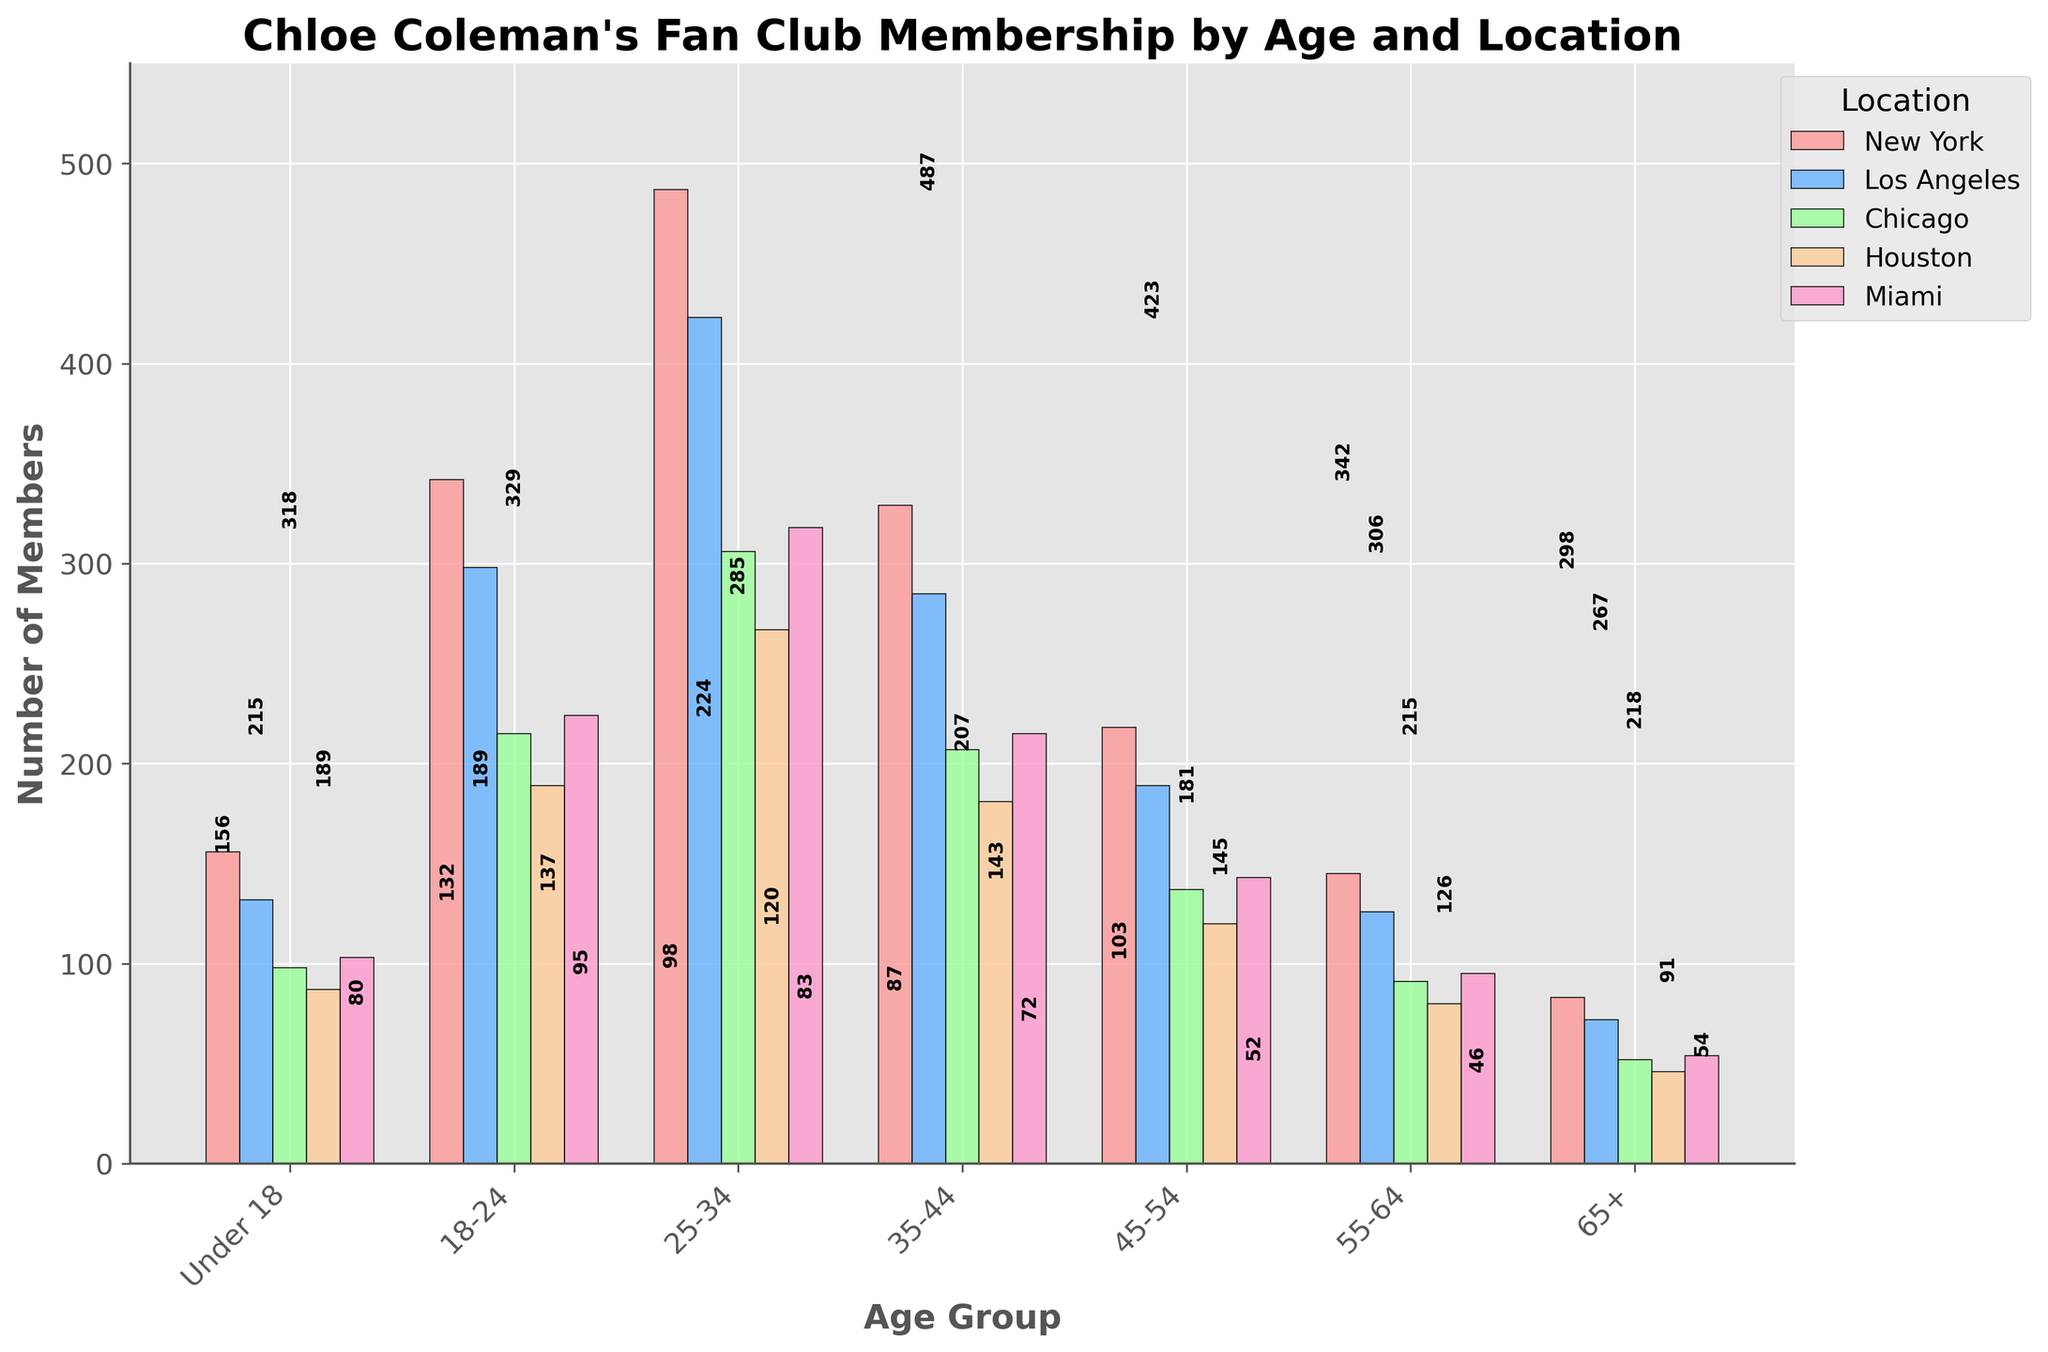What's the total number of members in the 25-34 age group across all locations? Sum the values for the 25-34 age group across New York, Los Angeles, Chicago, Houston, and Miami: (487 + 423 + 306 + 267 + 318) = 1801
Answer: 1801 Which location has the highest number of members in the 18-24 age group? Compare the number of members in the 18-24 age group across all locations: New York (342), Los Angeles (298), Chicago (215), Houston (189), and Miami (224). New York has the highest number.
Answer: New York What is the difference in the number of members between the under 18 and 65+ age groups in Los Angeles? Subtract the number of members in the 65+ age group from the number of members in the under 18 age group for Los Angeles: 132 - 72 = 60
Answer: 60 Which age group has the smallest number of members in Miami? Compare the number of members across different age groups in Miami. 65+ age group has 54, which is the smallest.
Answer: 65+ Among the listed locations, which age group shows the greatest variation in the number of members? Compare the range (difference between the maximum and minimum values) of the number of members across all age groups for each location. The 25-34 age group ranges from 267 (Houston) to 487 (New York), which is the greatest variation: 487 - 267 = 220.
Answer: 25-34 How many more members are there in the 55-64 age group in New York compared to Houston? Subtract the number of members in the 55-64 age group in Houston from New York: 145 - 80 = 65
Answer: 65 Which age group has roughly the same number of members across New York, Los Angeles, and Miami? Compare the number of members in each age group across New York, Los Angeles, and Miami. The 18-24 age group has numbers that are close: New York (342), Los Angeles (298), and Miami (224).
Answer: 18-24 In which city does the 35-44 age group have fewer members compared to the 45-54 age group? Compare the number of members in the 35-44 and 45-54 age groups for each city. Houston has 181 members in the 35-44 age group and 120 members in the 45-54 age group. None of the cities has fewer members in the 35-44 age group compared to the 45-54 age group.
Answer: None Which age group contributes the most to the total number of members in Chicago across all age groups? Compare the total number of members across all age groups for Chicago. The 25-34 age group has the most members with 306.
Answer: 25-34 